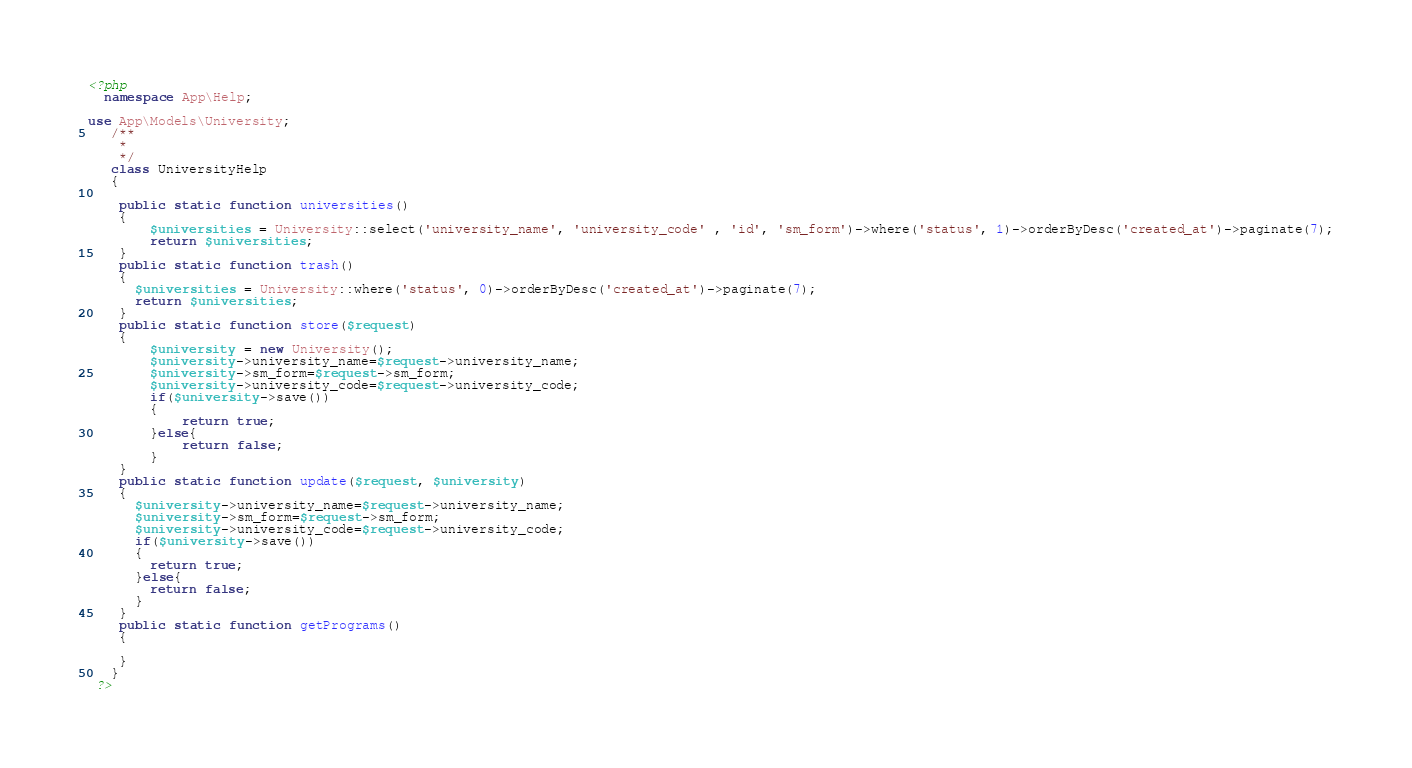<code> <loc_0><loc_0><loc_500><loc_500><_PHP_><?php 
  namespace App\Help;

use App\Models\University;
   /**
    * 
    */
   class UniversityHelp
   {
   	
   	public static function universities()
   	{
   		$universities = University::select('university_name', 'university_code' , 'id', 'sm_form')->where('status', 1)->orderByDesc('created_at')->paginate(7);
   		return $universities;
   	}
    public static function trash()
    {
      $universities = University::where('status', 0)->orderByDesc('created_at')->paginate(7);
      return $universities;
    }
   	public static function store($request)
   	{
   		$university = new University();
   		$university->university_name=$request->university_name;
   		$university->sm_form=$request->sm_form;
   		$university->university_code=$request->university_code;
   		if($university->save())
   		{
   			return true;
   		}else{
   			return false;
   		}
   	}
    public static function update($request, $university)
    {
      $university->university_name=$request->university_name;
      $university->sm_form=$request->sm_form;
      $university->university_code=$request->university_code;
      if($university->save())
      {
        return true;
      }else{
        return false;
      }
    }
    public static function getPrograms()
    {
      
    }
   }
 ?></code> 